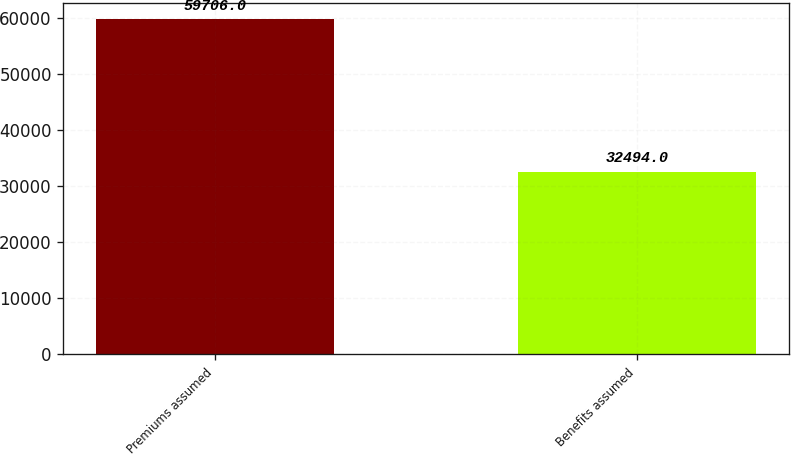<chart> <loc_0><loc_0><loc_500><loc_500><bar_chart><fcel>Premiums assumed<fcel>Benefits assumed<nl><fcel>59706<fcel>32494<nl></chart> 